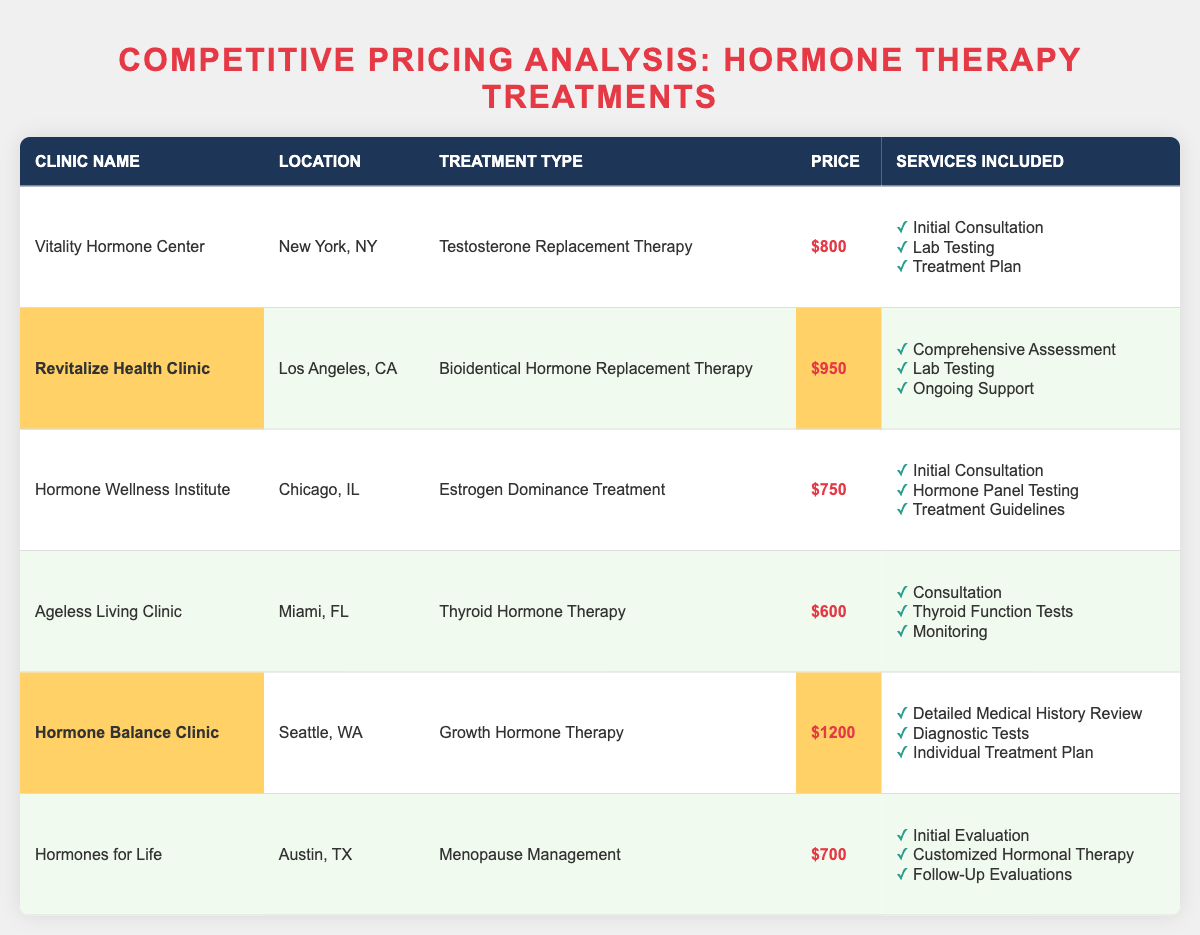What is the price of Testosterone Replacement Therapy at Vitality Hormone Center? The table lists the price for Testosterone Replacement Therapy at Vitality Hormone Center as $800.
Answer: $800 Which clinic offers the highest price for hormone therapy treatments? By comparing the prices listed, Hormone Balance Clinic has the highest price at $1200 for Growth Hormone Therapy.
Answer: Hormone Balance Clinic Is there a clinic that offers hormone therapy treatments for less than $700? Upon reviewing the table, Ageless Living Clinic offers thyroid hormone therapy for $600, which is below $700.
Answer: Yes What services are included with the Bioidentical Hormone Replacement Therapy at Revitalize Health Clinic? From the table, the services included for this treatment at Revitalize Health Clinic are: Comprehensive Assessment, Lab Testing, and Ongoing Support.
Answer: Comprehensive Assessment, Lab Testing, Ongoing Support What is the average price of the hormone therapies listed in the table? To calculate the average, sum the prices: $800 + $950 + $750 + $600 + $1200 + $700 = $4050. There are 6 clinics, so the average price is $4050 divided by 6, which equals $675.
Answer: $675 What treatment is offered by Ageless Living Clinic? The table specifies that Ageless Living Clinic offers Thyroid Hormone Therapy.
Answer: Thyroid Hormone Therapy How many clinics provide services for menopause management? By reviewing the table, Hormones for Life is the only clinic that provides services for menopause management.
Answer: One What is the difference in price between the most expensive and the least expensive treatments? The most expensive treatment is at Hormone Balance Clinic for $1200, and the least expensive is at Ageless Living Clinic for $600. The difference is $1200 - $600 = $600.
Answer: $600 